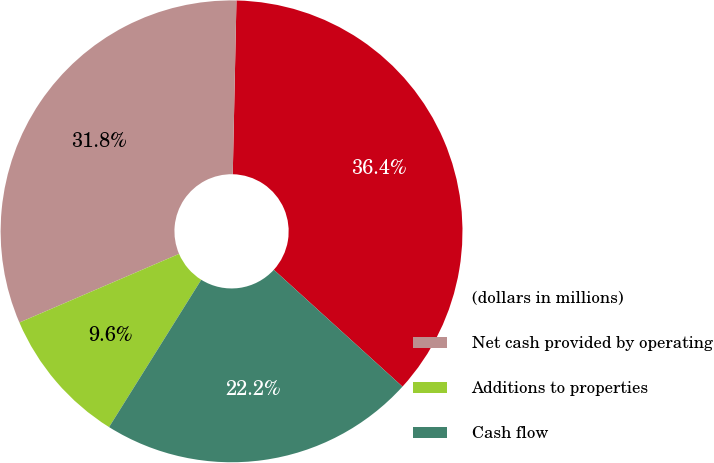Convert chart to OTSL. <chart><loc_0><loc_0><loc_500><loc_500><pie_chart><fcel>(dollars in millions)<fcel>Net cash provided by operating<fcel>Additions to properties<fcel>Cash flow<nl><fcel>36.4%<fcel>31.8%<fcel>9.64%<fcel>22.16%<nl></chart> 